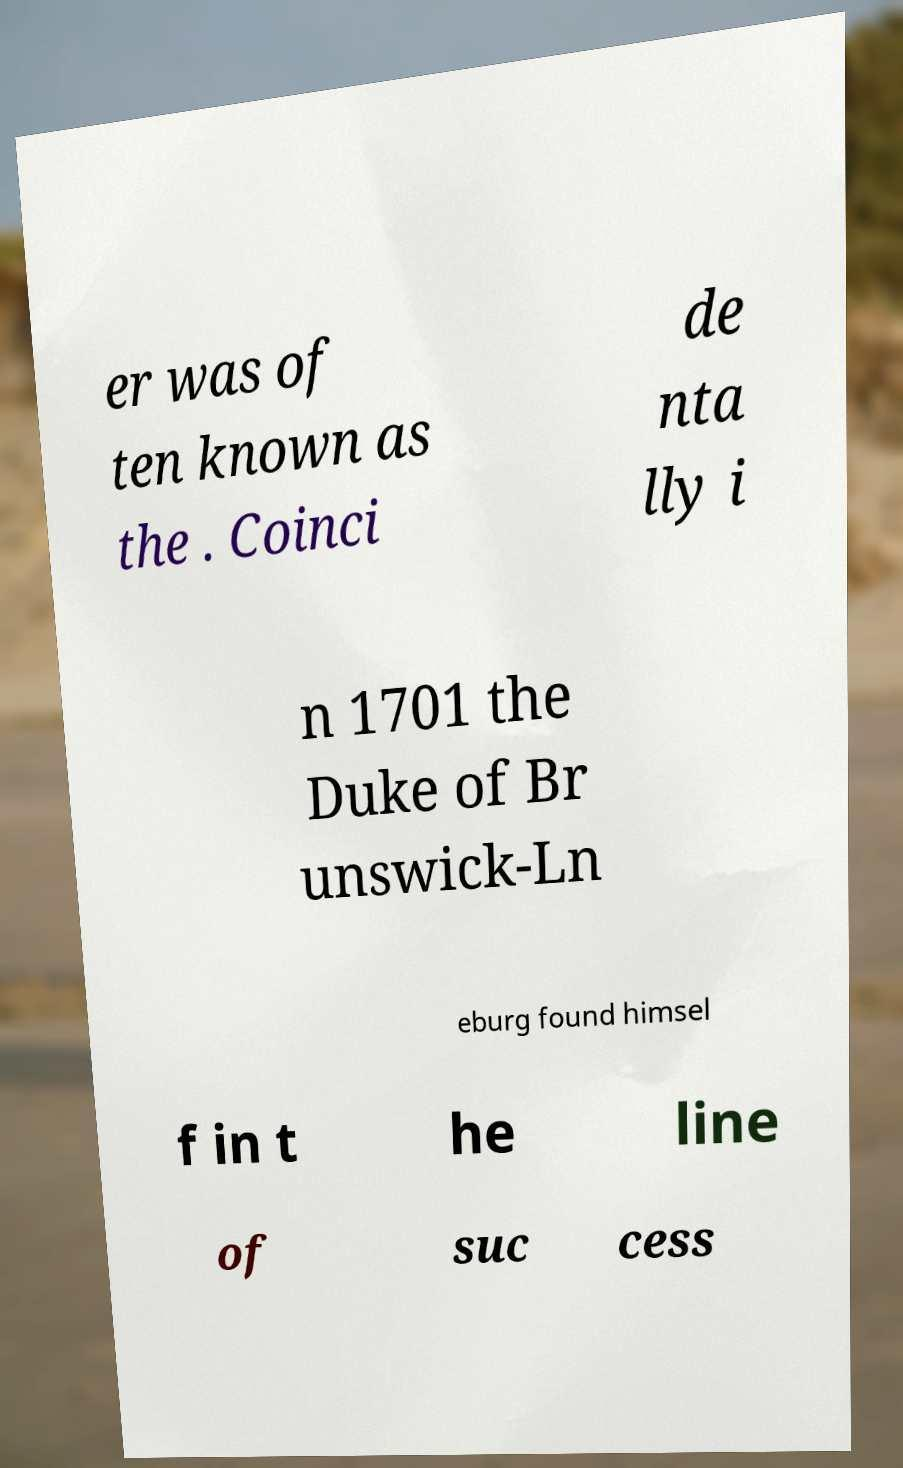Could you assist in decoding the text presented in this image and type it out clearly? er was of ten known as the . Coinci de nta lly i n 1701 the Duke of Br unswick-Ln eburg found himsel f in t he line of suc cess 